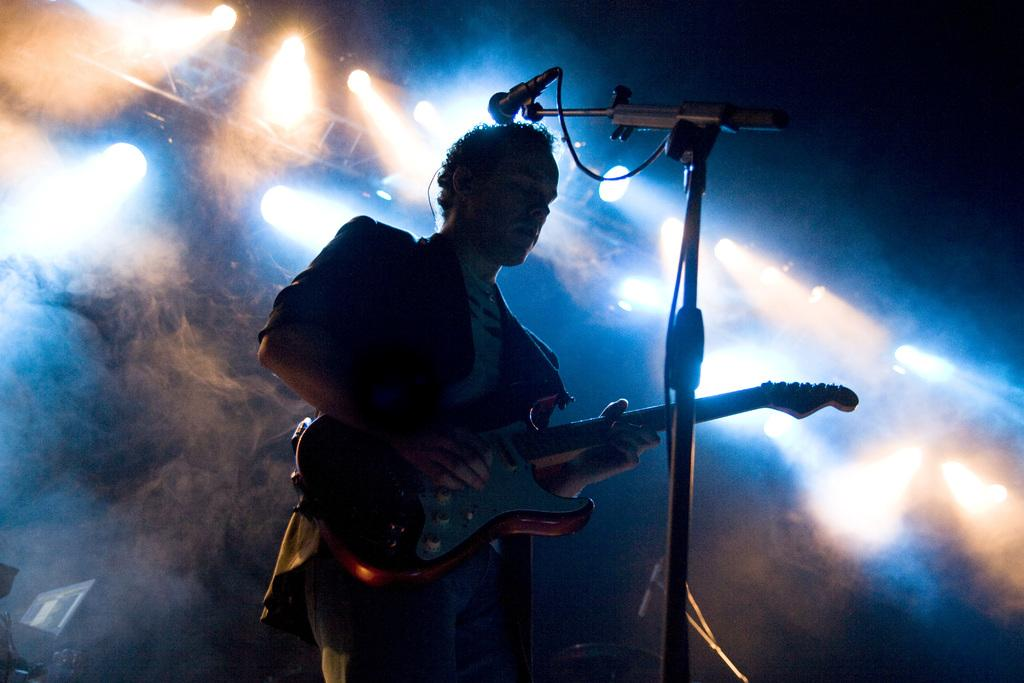Who is the main subject in the image? There is a man in the image. What is the man wearing? The man is wearing a blazer and jeans. What is the man doing in the image? The man is playing a guitar. What is in front of the man? There is a microphone in front of the man. What can be seen in the background of the image? There are lights and smoke in the background of the image. What type of building can be seen behind the man in the image? There is no building visible in the image; it features a man playing a guitar with a background of lights and smoke. Can you tell me how many robins are perched on the microphone in the image? There are no robins present in the image; it features a man playing a guitar with a microphone in front of him. 